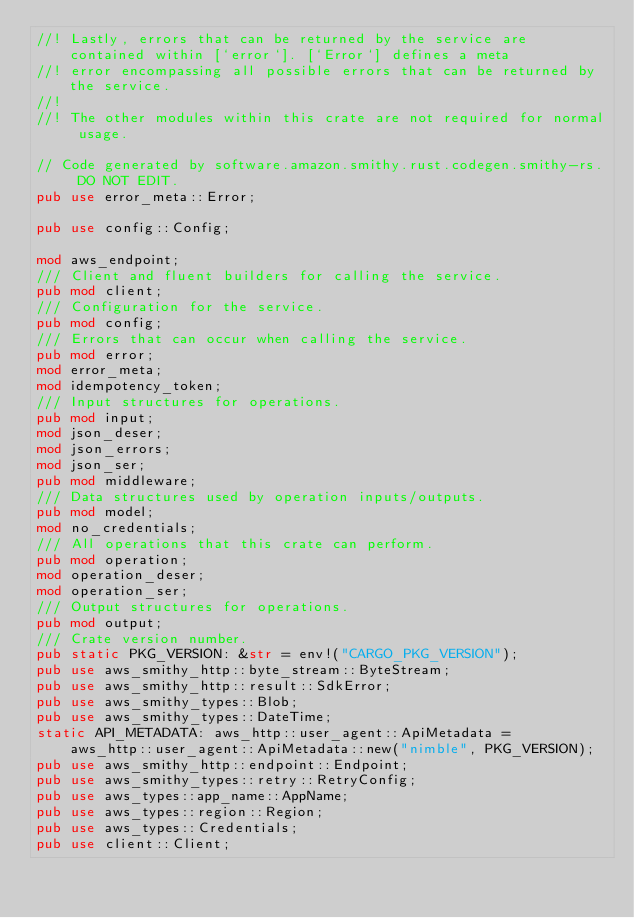<code> <loc_0><loc_0><loc_500><loc_500><_Rust_>//! Lastly, errors that can be returned by the service are contained within [`error`]. [`Error`] defines a meta
//! error encompassing all possible errors that can be returned by the service.
//!
//! The other modules within this crate are not required for normal usage.

// Code generated by software.amazon.smithy.rust.codegen.smithy-rs. DO NOT EDIT.
pub use error_meta::Error;

pub use config::Config;

mod aws_endpoint;
/// Client and fluent builders for calling the service.
pub mod client;
/// Configuration for the service.
pub mod config;
/// Errors that can occur when calling the service.
pub mod error;
mod error_meta;
mod idempotency_token;
/// Input structures for operations.
pub mod input;
mod json_deser;
mod json_errors;
mod json_ser;
pub mod middleware;
/// Data structures used by operation inputs/outputs.
pub mod model;
mod no_credentials;
/// All operations that this crate can perform.
pub mod operation;
mod operation_deser;
mod operation_ser;
/// Output structures for operations.
pub mod output;
/// Crate version number.
pub static PKG_VERSION: &str = env!("CARGO_PKG_VERSION");
pub use aws_smithy_http::byte_stream::ByteStream;
pub use aws_smithy_http::result::SdkError;
pub use aws_smithy_types::Blob;
pub use aws_smithy_types::DateTime;
static API_METADATA: aws_http::user_agent::ApiMetadata =
    aws_http::user_agent::ApiMetadata::new("nimble", PKG_VERSION);
pub use aws_smithy_http::endpoint::Endpoint;
pub use aws_smithy_types::retry::RetryConfig;
pub use aws_types::app_name::AppName;
pub use aws_types::region::Region;
pub use aws_types::Credentials;
pub use client::Client;
</code> 